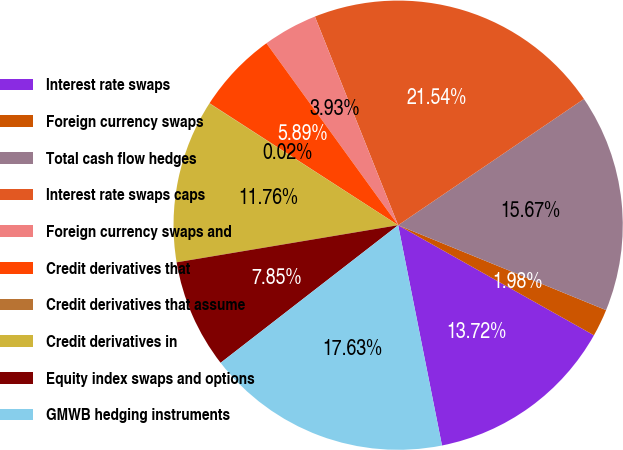<chart> <loc_0><loc_0><loc_500><loc_500><pie_chart><fcel>Interest rate swaps<fcel>Foreign currency swaps<fcel>Total cash flow hedges<fcel>Interest rate swaps caps<fcel>Foreign currency swaps and<fcel>Credit derivatives that<fcel>Credit derivatives that assume<fcel>Credit derivatives in<fcel>Equity index swaps and options<fcel>GMWB hedging instruments<nl><fcel>13.72%<fcel>1.98%<fcel>15.67%<fcel>21.54%<fcel>3.93%<fcel>5.89%<fcel>0.02%<fcel>11.76%<fcel>7.85%<fcel>17.63%<nl></chart> 